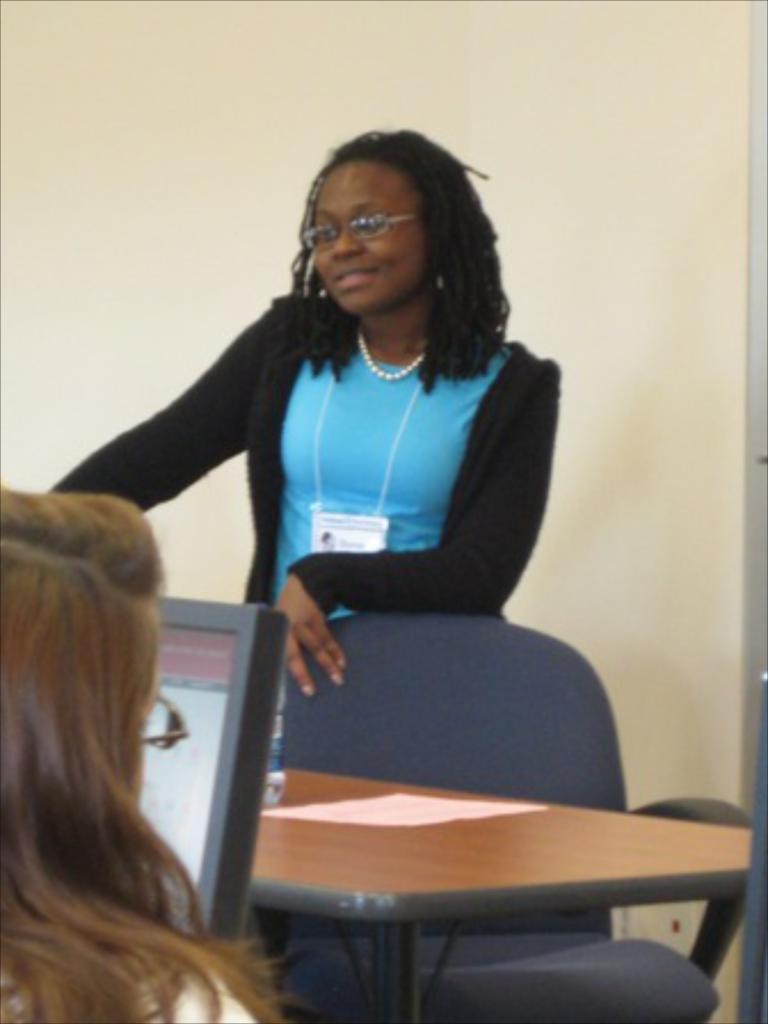Can you describe this image briefly? In this image i can see on the left side a person head and hair is visible. in front of her there is a system screen visible. and on the middle there is a table and chair and in front of the table a woman wearing blue color skirt she is smiling she is standing in front of the it. 